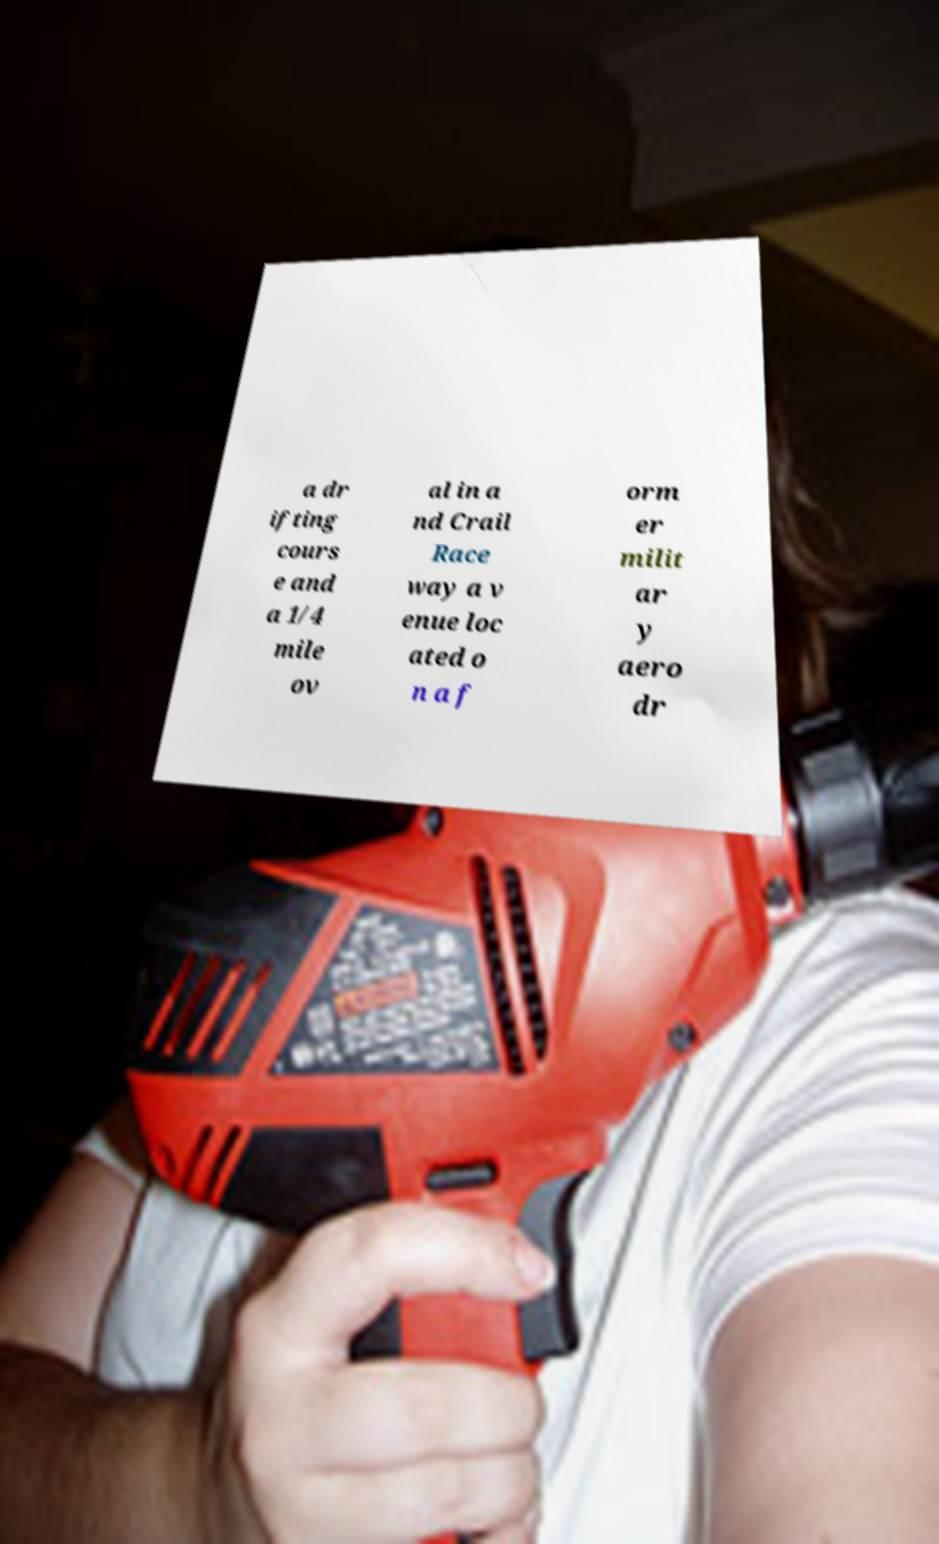I need the written content from this picture converted into text. Can you do that? a dr ifting cours e and a 1/4 mile ov al in a nd Crail Race way a v enue loc ated o n a f orm er milit ar y aero dr 